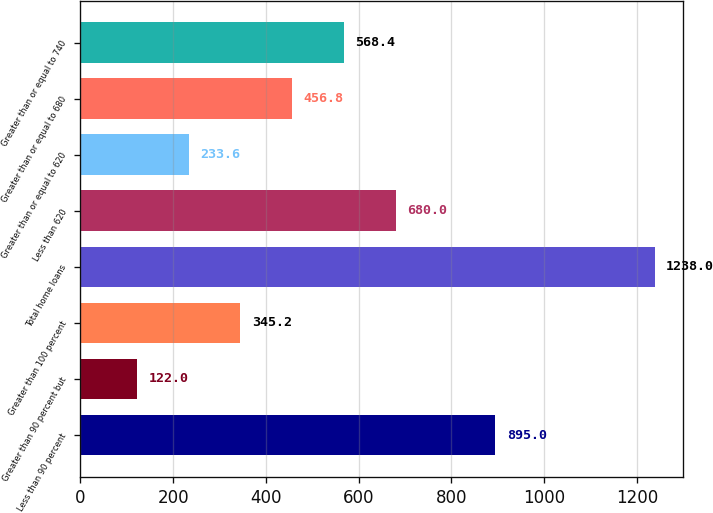Convert chart. <chart><loc_0><loc_0><loc_500><loc_500><bar_chart><fcel>Less than 90 percent<fcel>Greater than 90 percent but<fcel>Greater than 100 percent<fcel>Total home loans<fcel>Less than 620<fcel>Greater than or equal to 620<fcel>Greater than or equal to 680<fcel>Greater than or equal to 740<nl><fcel>895<fcel>122<fcel>345.2<fcel>1238<fcel>680<fcel>233.6<fcel>456.8<fcel>568.4<nl></chart> 